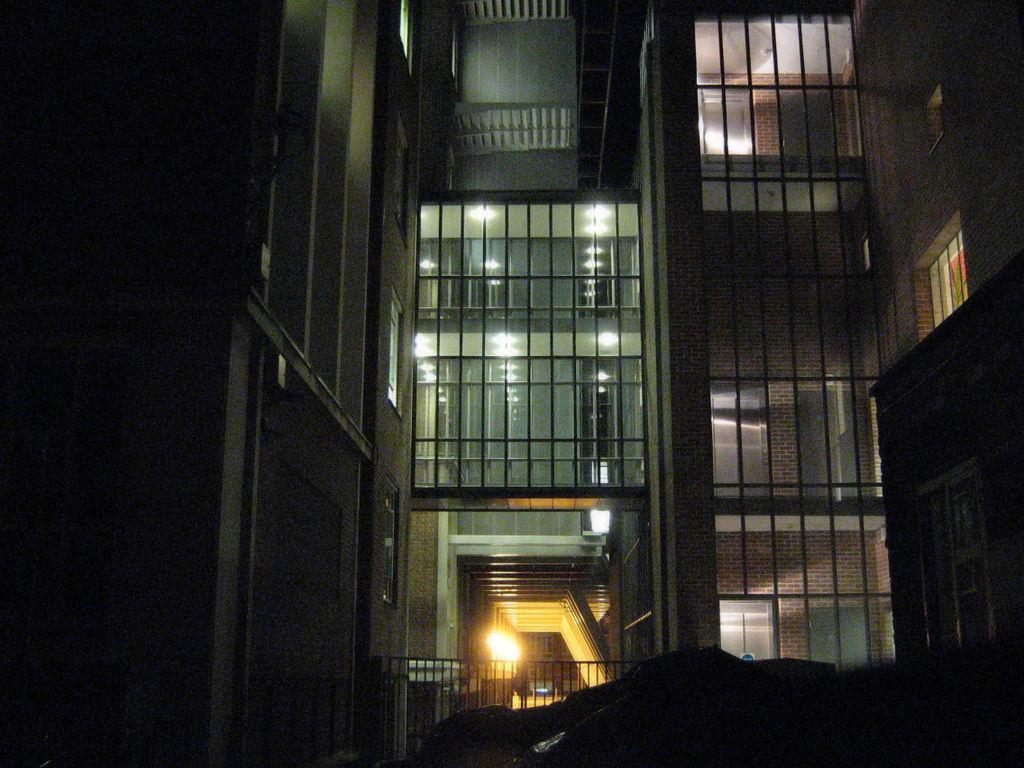What type of structure is in the image? There is a building in the image. What can be seen illuminated in the image? There are lights visible in the image. What objects are present in the image that might be used for drinking? There are glasses present in the image. What type of pleasure can be seen enjoying a yam in the image? There is no pleasure or yam present in the image; it only features a building, lights, and glasses. 